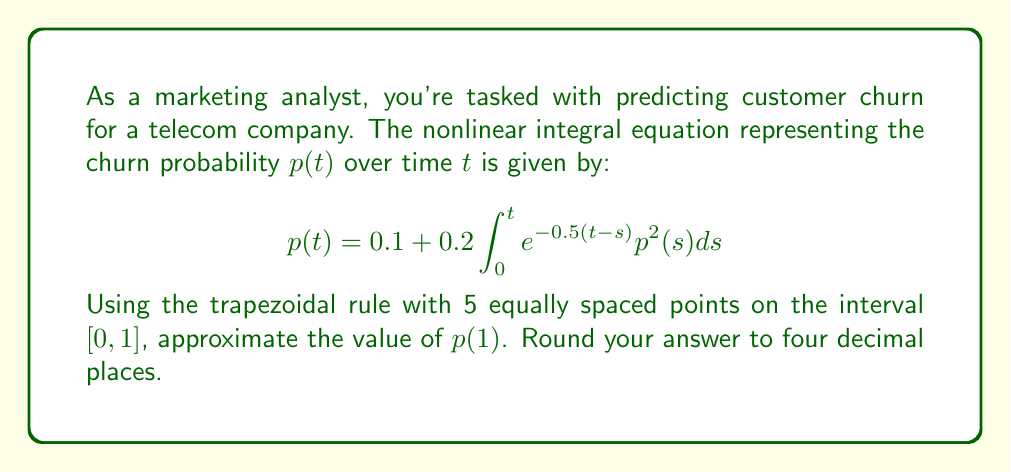Give your solution to this math problem. Let's solve this step-by-step using the trapezoidal rule:

1) First, we need to set up our grid. With 5 points on $[0, 1]$, our step size $h = 0.25$.
   Our points are $t_i = 0, 0.25, 0.5, 0.75, 1$.

2) We'll use the formula:
   $$p(t_i) = 0.1 + 0.2\int_0^{t_i} e^{-0.5(t_i-s)}p^2(s)ds$$

3) We can approximate this integral using the trapezoidal rule:
   $$\int_0^{t_i} f(s)ds \approx \frac{h}{2}[f(0) + 2f(t_1) + 2f(t_2) + ... + 2f(t_{i-1}) + f(t_i)]$$

4) Let's set up our iteration:
   $$p(t_i) = 0.1 + 0.1h[e^{-0.5t_i}p^2(0) + 2e^{-0.5(t_i-t_1)}p^2(t_1) + ... + 2e^{-0.5(t_i-t_{i-1})}p^2(t_{i-1}) + p^2(t_i)]$$

5) We start with $p(0) = 0.1$ (when $t = 0$, the integral is zero).

6) For $t_1 = 0.25$:
   $$p(0.25) = 0.1 + 0.1 \cdot 0.25 [e^{-0.5 \cdot 0.25} \cdot 0.1^2 + 0.1^2] = 0.1006$$

7) For $t_2 = 0.5$:
   $$p(0.5) = 0.1 + 0.1 \cdot 0.25 [e^{-0.5 \cdot 0.5} \cdot 0.1^2 + 2e^{-0.5 \cdot 0.25} \cdot 0.1006^2 + 0.1006^2] = 0.1025$$

8) For $t_3 = 0.75$:
   $$p(0.75) = 0.1 + 0.1 \cdot 0.25 [e^{-0.5 \cdot 0.75} \cdot 0.1^2 + 2e^{-0.5 \cdot 0.5} \cdot 0.1006^2 + 2e^{-0.5 \cdot 0.25} \cdot 0.1025^2 + 0.1025^2] = 0.1056$$

9) Finally, for $t_4 = 1$:
   $$p(1) = 0.1 + 0.1 \cdot 0.25 [e^{-0.5} \cdot 0.1^2 + 2e^{-0.5 \cdot 0.75} \cdot 0.1006^2 + 2e^{-0.5 \cdot 0.5} \cdot 0.1025^2 + 2e^{-0.5 \cdot 0.25} \cdot 0.1056^2 + 0.1056^2] = 0.1099$$

10) Rounding to four decimal places, we get 0.1099.
Answer: 0.1099 